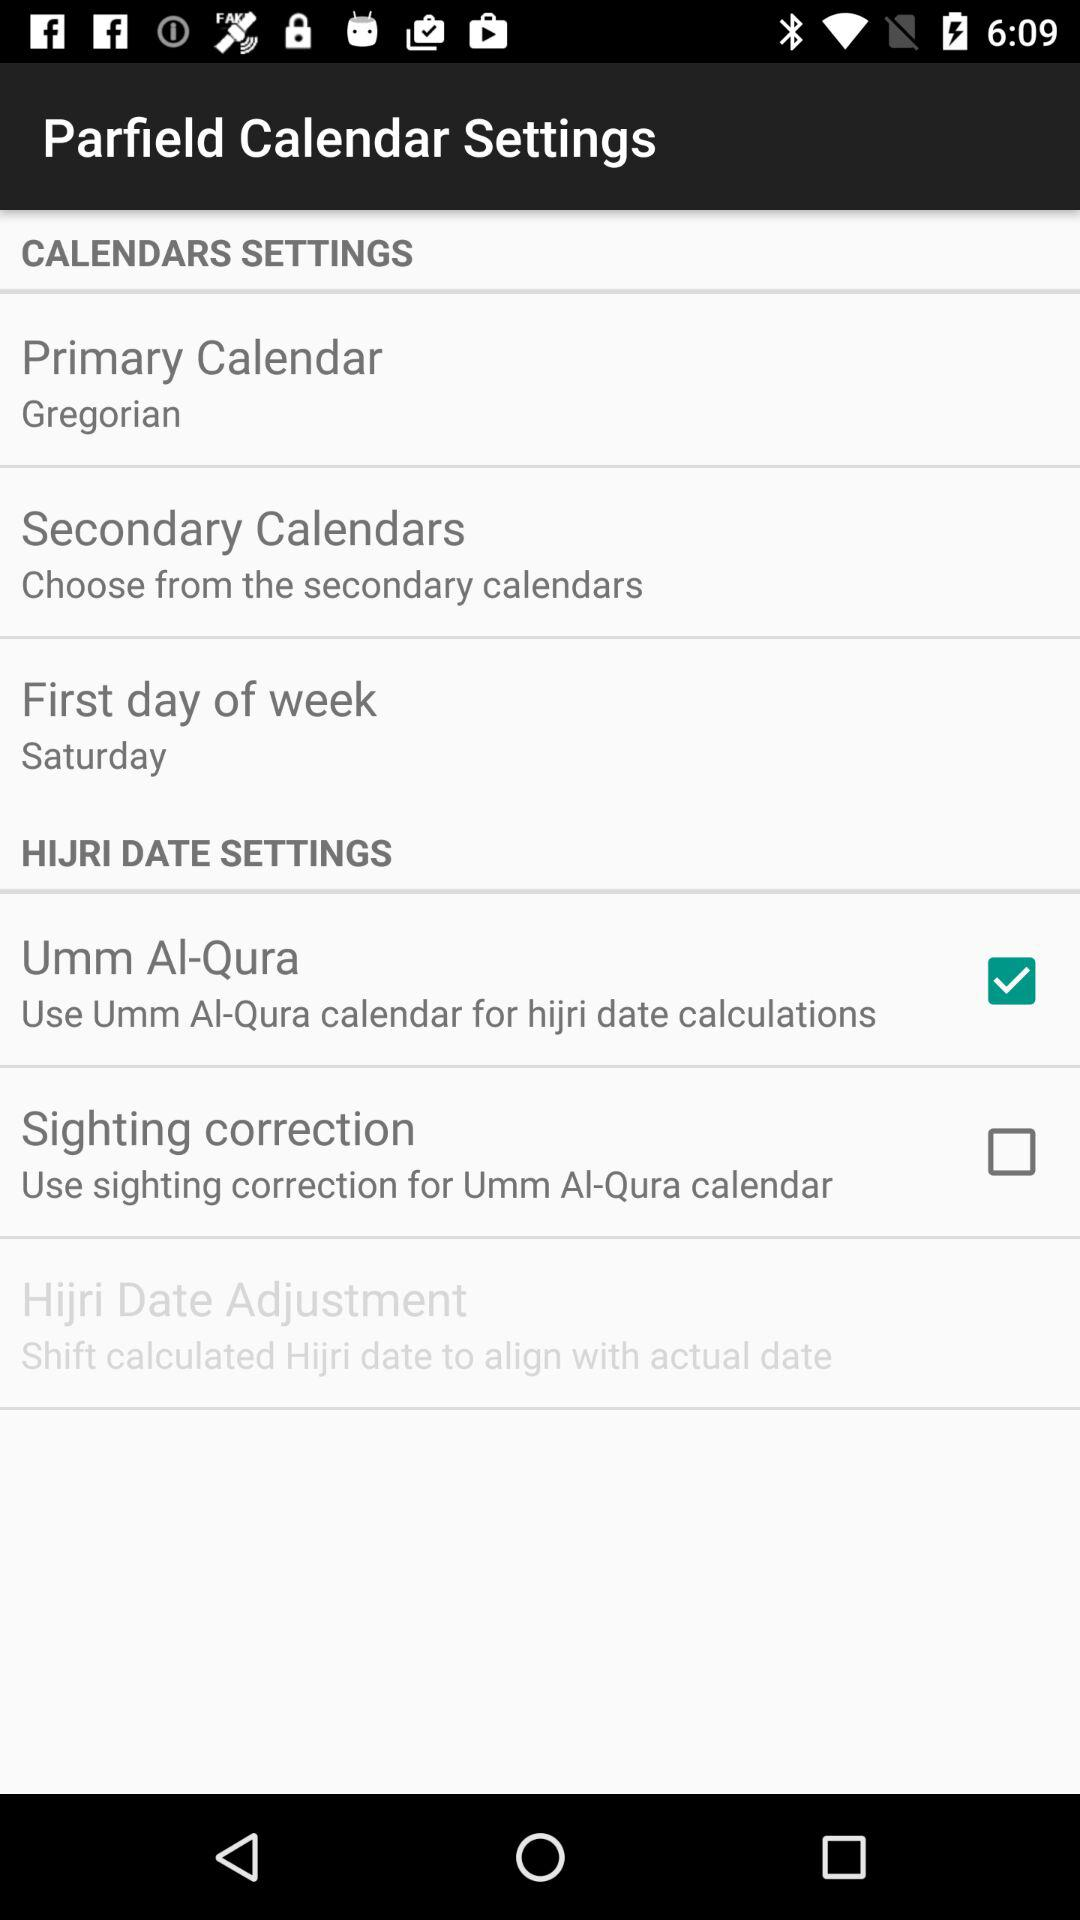What is the status of the "Umm Al-Qura"? The status is "on". 